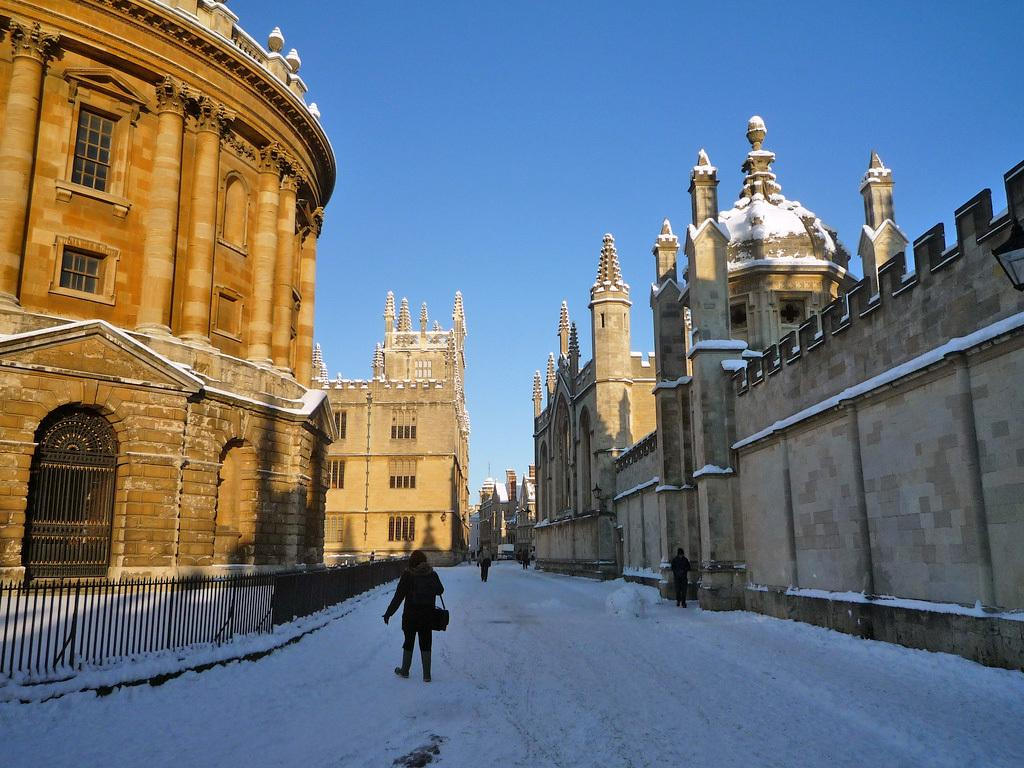What is happening on the road in the image? There are people on the road in the image. What can be seen on the left side of the image? There is a fence on the left side of the image. What is visible in the background of the image? There are buildings and the sky in the background of the image. What is the condition of the ground in the image? The ground appears to be covered in snow. What type of expansion is being carried out on the road in the image? There is no indication of any expansion being carried out on the road in the image. Can you see a cannon in the image? There is no cannon present in the image. 